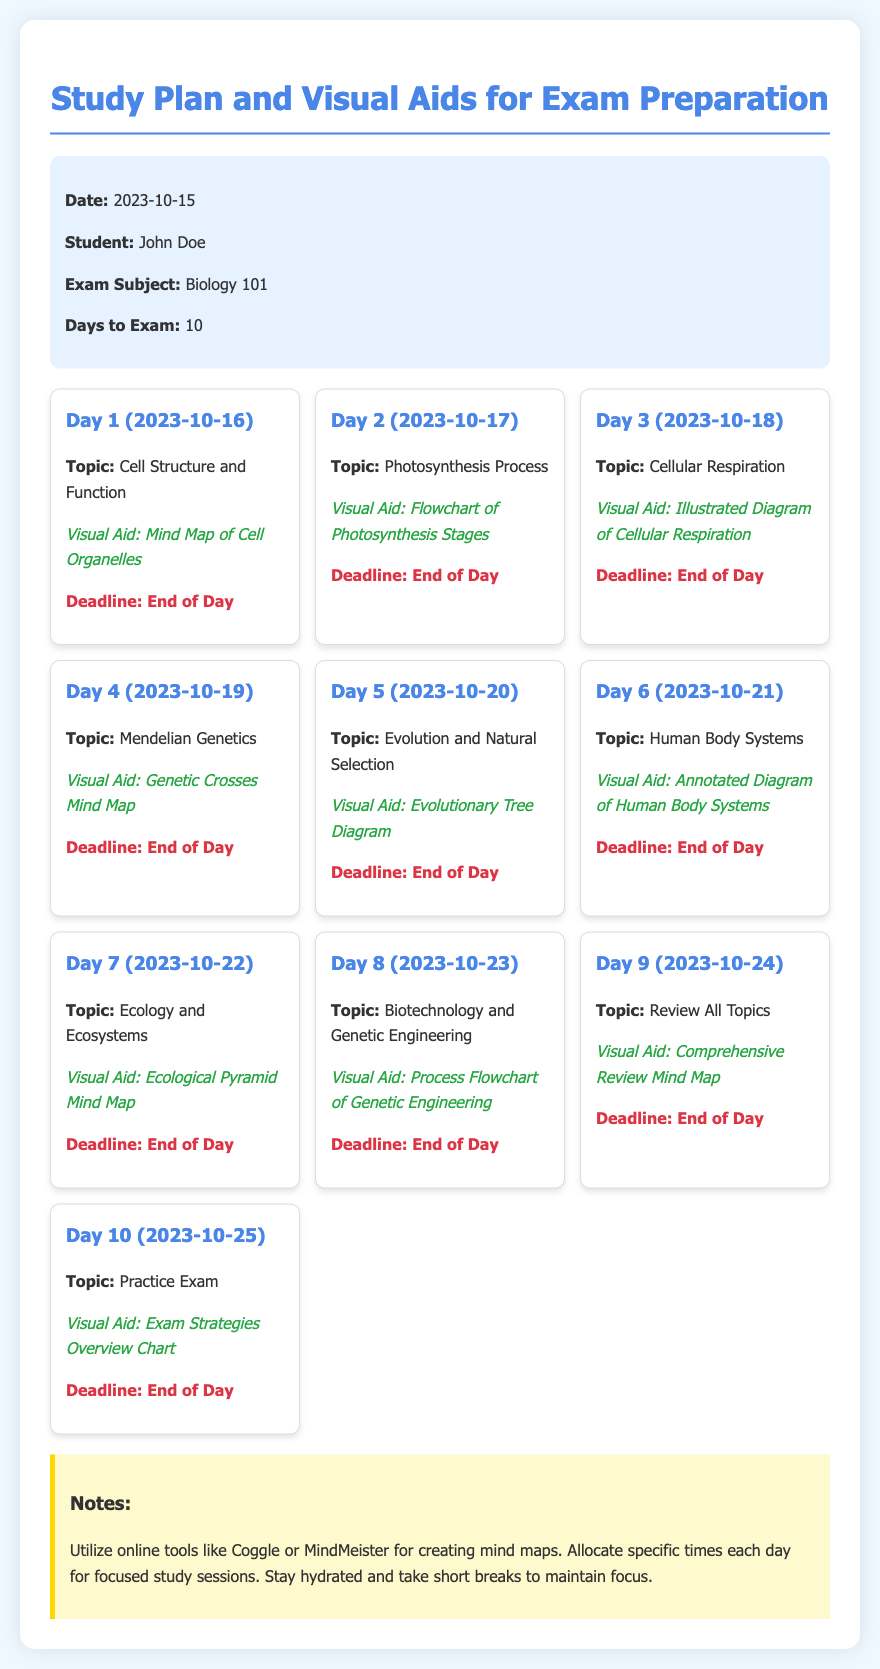What is the exam subject? The exam subject is specified in the memo under "Exam Subject."
Answer: Biology 101 How many days are left until the exam? The number of days until the exam is stated as "Days to Exam."
Answer: 10 What topic is covered on Day 5? The topic for Day 5 is listed explicitly for that day.
Answer: Evolution and Natural Selection What visual aid is suggested for Day 3? The visual aid for Day 3 is explicitly mentioned in the details for that day.
Answer: Illustrated Diagram of Cellular Respiration What date is Day 7? The date for Day 7 is provided in the memo.
Answer: 2023-10-22 Which online tools are suggested for creating mind maps? The memo mentions specific online tools for mind mapping in the notes section.
Answer: Coggle or MindMeister On which day is the practice exam scheduled? The day for the practice exam is provided explicitly.
Answer: Day 10 What is the visual aid for Day 9? The visual aid for Day 9 is specifically mentioned alongside the topic.
Answer: Comprehensive Review Mind Map 